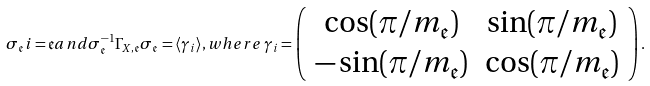Convert formula to latex. <formula><loc_0><loc_0><loc_500><loc_500>\sigma _ { \mathfrak { e } } i = \mathfrak { e } a n d \sigma _ { \mathfrak { e } } ^ { - 1 } \Gamma _ { X , \mathfrak { e } } \sigma _ { \mathfrak { e } } = \langle \gamma _ { i } \rangle , w h e r e \, \gamma _ { i } = \left ( \begin{array} { c c c } \cos ( \pi \slash m _ { \mathfrak { e } } ) & \sin ( \pi \slash m _ { \mathfrak { e } } ) \\ - \sin ( \pi \slash m _ { \mathfrak { e } } ) & \cos ( \pi \slash m _ { \mathfrak { e } } ) \end{array} \right ) .</formula> 